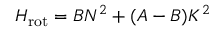<formula> <loc_0><loc_0><loc_500><loc_500>H _ { r o t } = B N ^ { 2 } + ( A - B ) K ^ { 2 }</formula> 